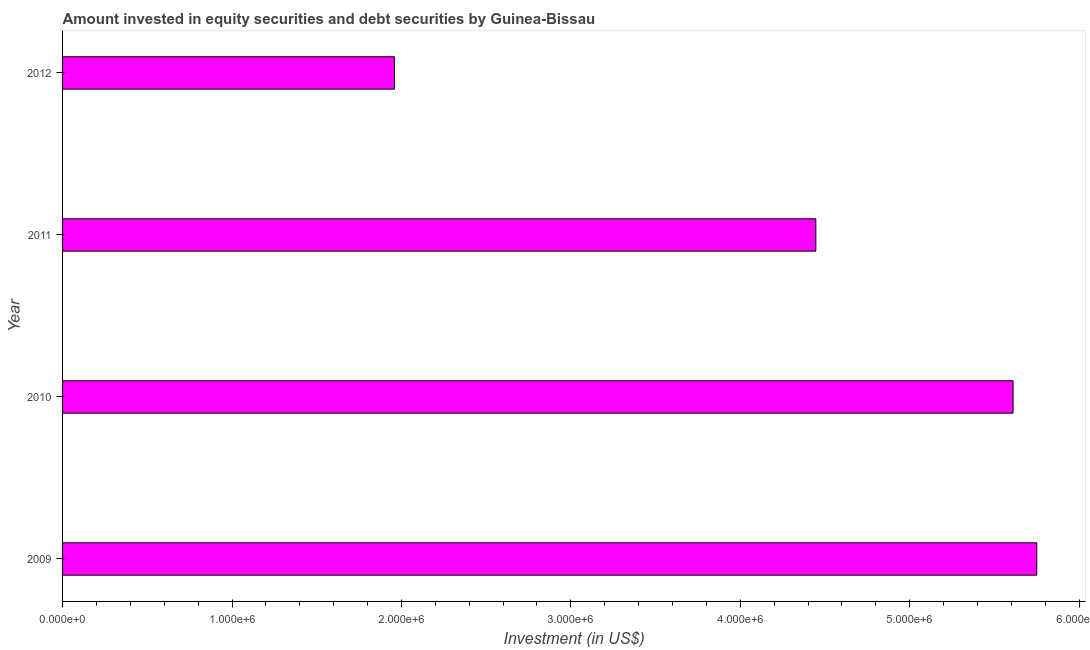What is the title of the graph?
Offer a very short reply. Amount invested in equity securities and debt securities by Guinea-Bissau. What is the label or title of the X-axis?
Ensure brevity in your answer.  Investment (in US$). What is the label or title of the Y-axis?
Provide a short and direct response. Year. What is the portfolio investment in 2012?
Your answer should be very brief. 1.96e+06. Across all years, what is the maximum portfolio investment?
Your answer should be very brief. 5.75e+06. Across all years, what is the minimum portfolio investment?
Ensure brevity in your answer.  1.96e+06. In which year was the portfolio investment minimum?
Keep it short and to the point. 2012. What is the sum of the portfolio investment?
Make the answer very short. 1.78e+07. What is the difference between the portfolio investment in 2009 and 2011?
Offer a terse response. 1.30e+06. What is the average portfolio investment per year?
Offer a terse response. 4.44e+06. What is the median portfolio investment?
Keep it short and to the point. 5.03e+06. What is the ratio of the portfolio investment in 2011 to that in 2012?
Make the answer very short. 2.27. What is the difference between the highest and the second highest portfolio investment?
Offer a very short reply. 1.40e+05. Is the sum of the portfolio investment in 2011 and 2012 greater than the maximum portfolio investment across all years?
Keep it short and to the point. Yes. What is the difference between the highest and the lowest portfolio investment?
Your answer should be compact. 3.79e+06. In how many years, is the portfolio investment greater than the average portfolio investment taken over all years?
Make the answer very short. 3. What is the difference between two consecutive major ticks on the X-axis?
Your answer should be very brief. 1.00e+06. Are the values on the major ticks of X-axis written in scientific E-notation?
Offer a terse response. Yes. What is the Investment (in US$) in 2009?
Make the answer very short. 5.75e+06. What is the Investment (in US$) of 2010?
Offer a terse response. 5.61e+06. What is the Investment (in US$) of 2011?
Offer a terse response. 4.45e+06. What is the Investment (in US$) of 2012?
Your answer should be compact. 1.96e+06. What is the difference between the Investment (in US$) in 2009 and 2010?
Provide a succinct answer. 1.40e+05. What is the difference between the Investment (in US$) in 2009 and 2011?
Your answer should be compact. 1.30e+06. What is the difference between the Investment (in US$) in 2009 and 2012?
Keep it short and to the point. 3.79e+06. What is the difference between the Investment (in US$) in 2010 and 2011?
Give a very brief answer. 1.16e+06. What is the difference between the Investment (in US$) in 2010 and 2012?
Your answer should be very brief. 3.65e+06. What is the difference between the Investment (in US$) in 2011 and 2012?
Provide a short and direct response. 2.49e+06. What is the ratio of the Investment (in US$) in 2009 to that in 2010?
Your answer should be compact. 1.02. What is the ratio of the Investment (in US$) in 2009 to that in 2011?
Your answer should be very brief. 1.29. What is the ratio of the Investment (in US$) in 2009 to that in 2012?
Make the answer very short. 2.94. What is the ratio of the Investment (in US$) in 2010 to that in 2011?
Your answer should be very brief. 1.26. What is the ratio of the Investment (in US$) in 2010 to that in 2012?
Your answer should be compact. 2.86. What is the ratio of the Investment (in US$) in 2011 to that in 2012?
Provide a succinct answer. 2.27. 